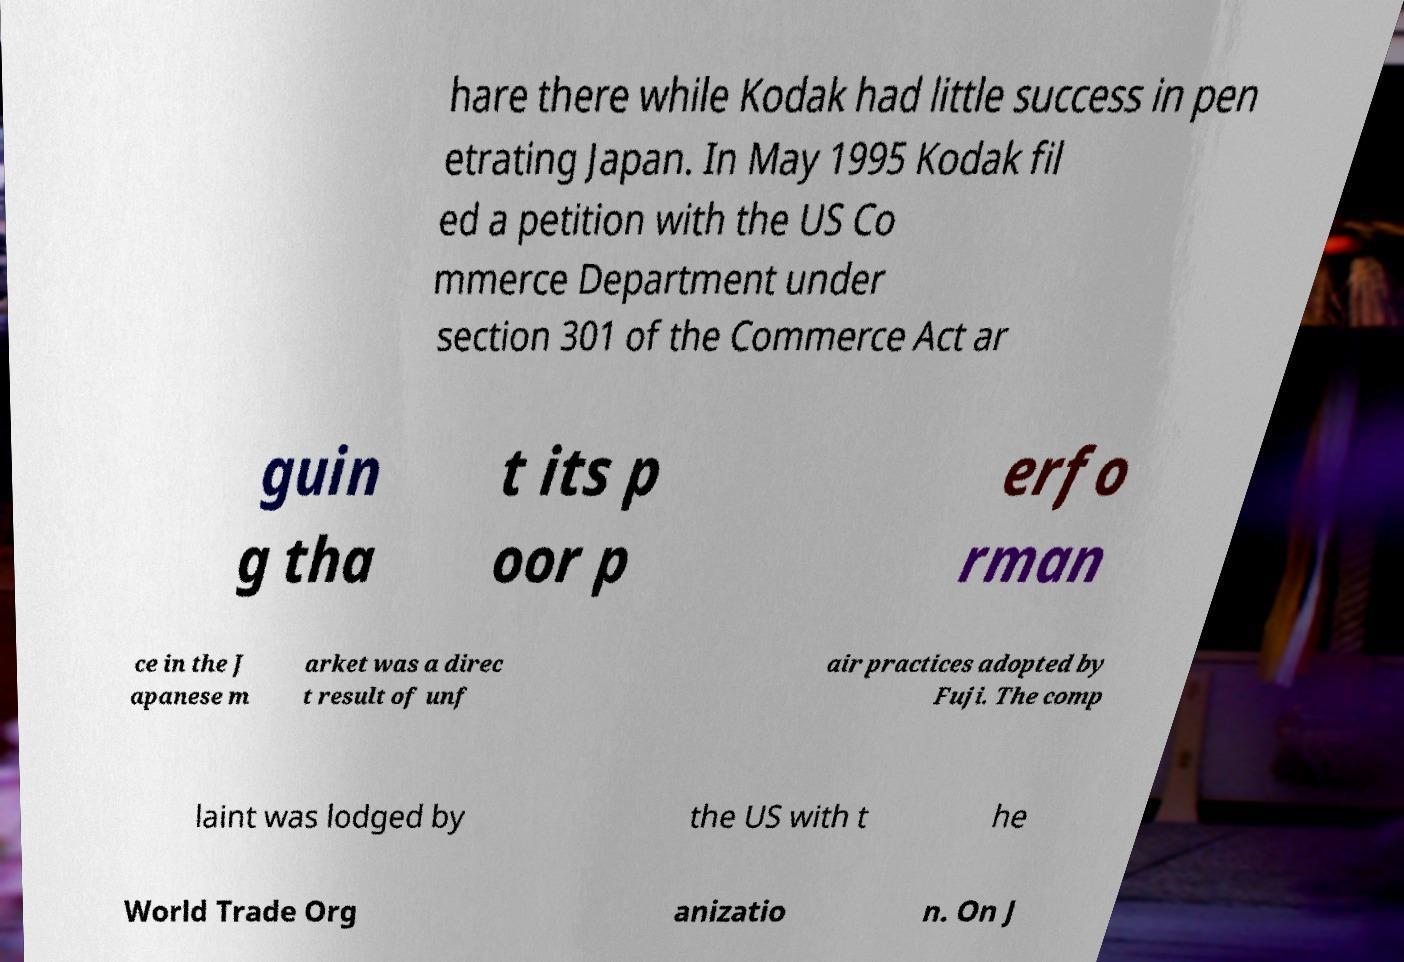Could you extract and type out the text from this image? hare there while Kodak had little success in pen etrating Japan. In May 1995 Kodak fil ed a petition with the US Co mmerce Department under section 301 of the Commerce Act ar guin g tha t its p oor p erfo rman ce in the J apanese m arket was a direc t result of unf air practices adopted by Fuji. The comp laint was lodged by the US with t he World Trade Org anizatio n. On J 